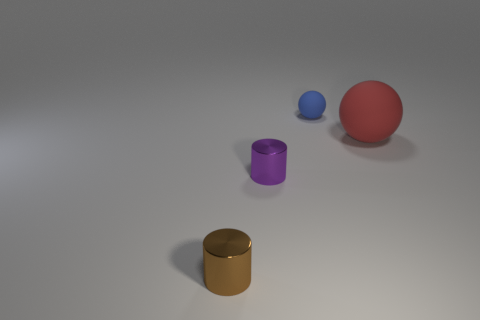Are there any other things that are the same size as the red matte object?
Your response must be concise. No. There is a small cylinder that is in front of the cylinder behind the small brown metal thing; what is its material?
Your answer should be very brief. Metal. Are there fewer small rubber spheres to the left of the tiny blue rubber sphere than small metal cylinders behind the small brown metallic object?
Keep it short and to the point. Yes. What number of cyan objects are spheres or cylinders?
Make the answer very short. 0. Are there the same number of blue objects that are on the left side of the small purple shiny cylinder and small green metal blocks?
Offer a terse response. Yes. What number of things are either large red objects or tiny metal things that are on the right side of the brown thing?
Provide a succinct answer. 2. Are there any other small objects made of the same material as the red object?
Give a very brief answer. Yes. What color is the other tiny object that is the same shape as the small purple metallic object?
Provide a succinct answer. Brown. Is the material of the purple cylinder the same as the small object that is behind the large rubber ball?
Provide a succinct answer. No. There is a shiny object to the right of the tiny metal cylinder that is left of the purple object; what is its shape?
Offer a very short reply. Cylinder. 